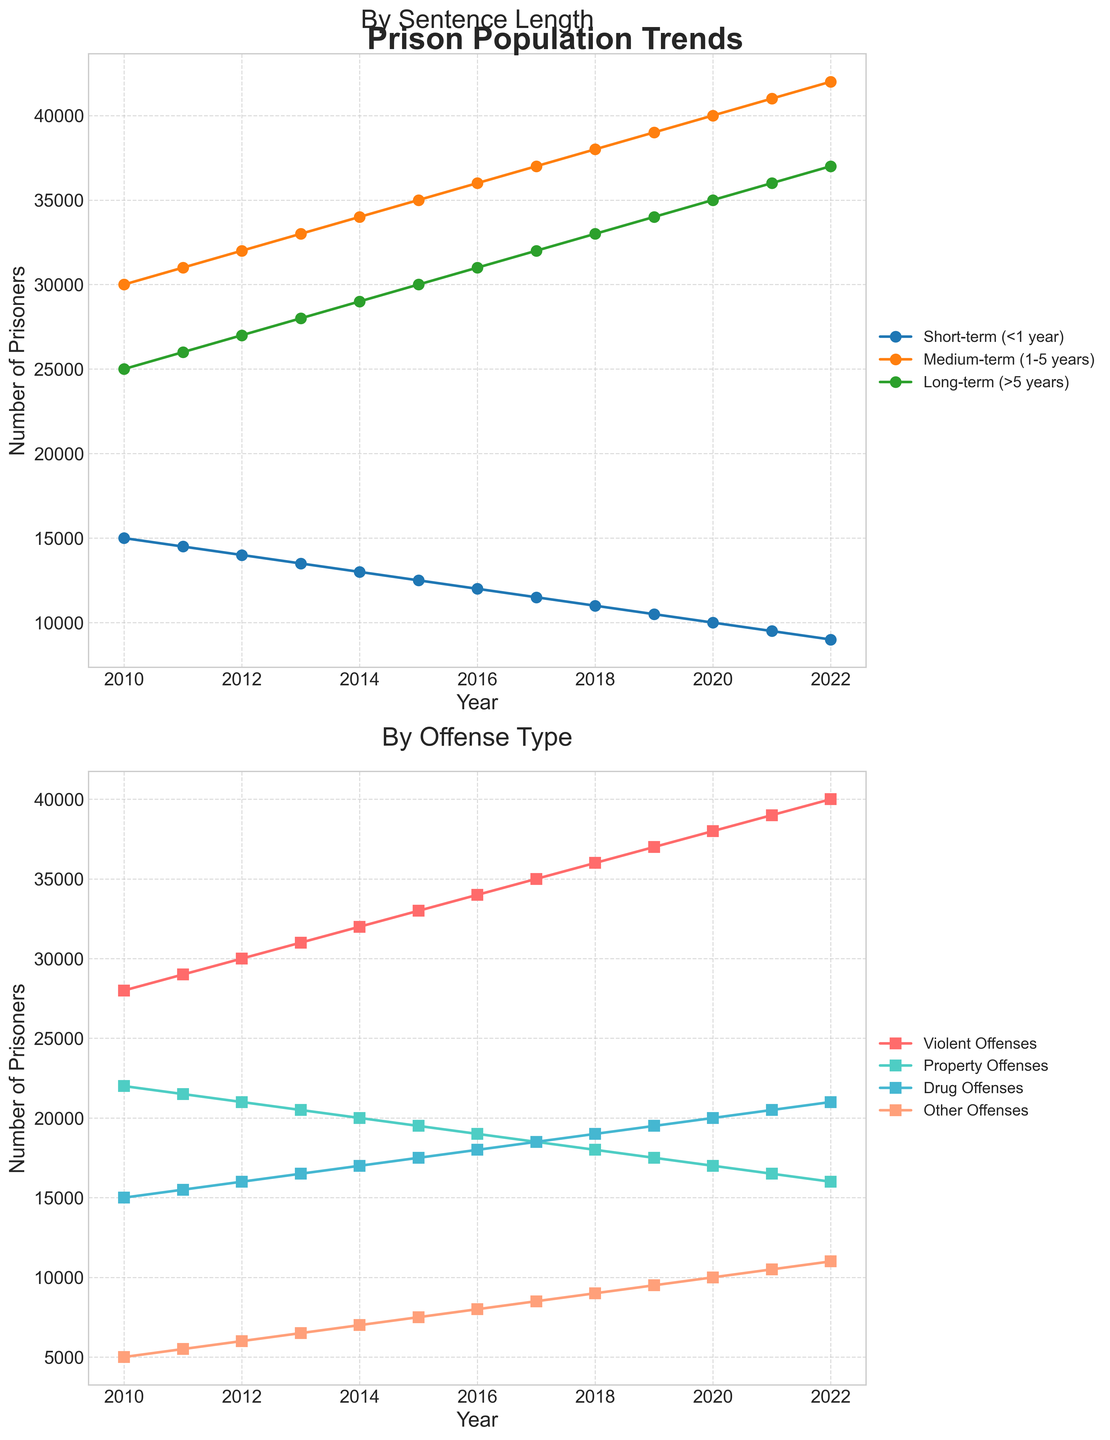What trend do you observe in the population of prisoners serving short-term sentences (<1 year) from 2010 to 2022? By looking at the line representing short-term sentences in the top plot, one can observe a continuous decline from 15,000 prisoners in 2010 to 9,000 prisoners in 2022.
Answer: Continuous decline How did the total number of prisoners sentenced to medium-term (1-5 years) change over the observed period? Provide the calculation steps. In 2010, there were 30,000 prisoners with medium-term sentences. By 2022, this number increased to 42,000. Therefore, the change is 42,000 - 30,000 = 12,000, showing a net increase of 12,000 prisoners over the period.
Answer: Increase of 12,000 Which offense type saw the largest increase in prisoner numbers between 2010 and 2022? Comparing the lines for each offense type in the bottom plot: Violent Offenses increased from 28,000 to 40,000 (12,000 increase), Property Offenses decreased from 22,000 to 16,000 (6,000 decrease), Drug Offenses increased from 15,000 to 21,000 (6,000 increase), and Other Offenses increased from 5,000 to 11,000 (6,000 increase). Violent Offenses saw the largest increase.
Answer: Violent Offenses In which year did the number of prisoners serving long-term sentences (>5 years) surpass 30,000 for the first time? Observing the line for long-term sentences in the top plot, it surpasses 30,000 prisoners in 2015.
Answer: 2015 Compare the number of prisoners serving medium-term (1-5 years) sentences to those serving long-term (>5 years) sentences in 2018. Which group is larger and by how much? In 2018, the number of prisoners serving medium-term sentences is 38,000, and the number serving long-term sentences is 33,000. The medium-term group is larger by 38,000 - 33,000 = 5,000 prisoners.
Answer: Medium-term, 5,000 What is the difference between the number of prisoners serving short-term sentences in 2010 and in 2022? The number of short-term prisoners in 2010 was 15,000, while in 2022 it was 9,000. The difference is 15,000 - 9,000 = 6,000 prisoners.
Answer: Difference of 6,000 Compare the trend lines for Drug Offenses and Other Offenses. Do they follow a similar pattern? Observing the bottom plot, both Drug Offenses and Other Offenses show an increasing trend over the years, with gradual year-on-year increases.
Answer: Yes, similar pattern Calculate the average number of prisoners for Property Offenses over the entire period. Provide the calculation. The numbers are: 22,000 (2010), 21,500 (2011), 21,000 (2012), 20,500 (2013), 20,000 (2014), 19,500 (2015), 19,000 (2016), 18,500 (2017), 18,000 (2018), 17,500 (2019), 17,000 (2020), 16,500 (2021), 16,000 (2022). Sum these numbers to get 246,000. Dividing by 13 years, the average is 246,000 / 13 ≈ 18,923 prisoners.
Answer: 18,923 